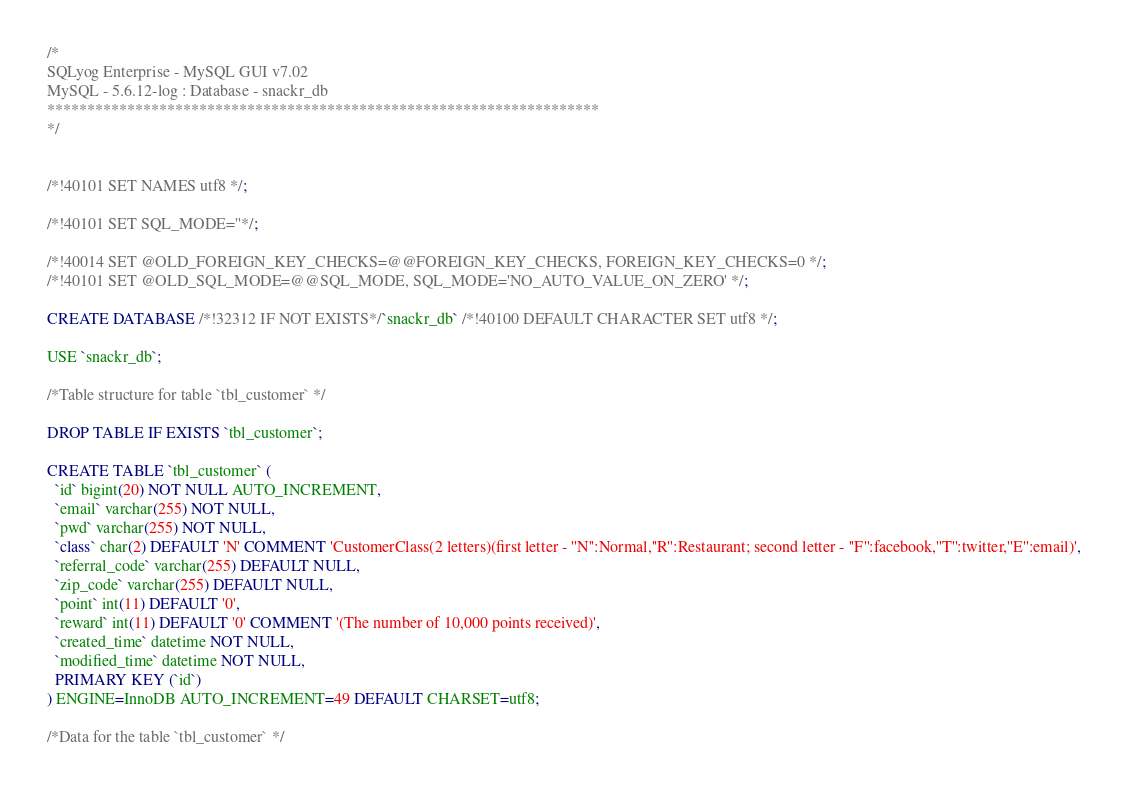Convert code to text. <code><loc_0><loc_0><loc_500><loc_500><_SQL_>/*
SQLyog Enterprise - MySQL GUI v7.02 
MySQL - 5.6.12-log : Database - snackr_db
*********************************************************************
*/

/*!40101 SET NAMES utf8 */;

/*!40101 SET SQL_MODE=''*/;

/*!40014 SET @OLD_FOREIGN_KEY_CHECKS=@@FOREIGN_KEY_CHECKS, FOREIGN_KEY_CHECKS=0 */;
/*!40101 SET @OLD_SQL_MODE=@@SQL_MODE, SQL_MODE='NO_AUTO_VALUE_ON_ZERO' */;

CREATE DATABASE /*!32312 IF NOT EXISTS*/`snackr_db` /*!40100 DEFAULT CHARACTER SET utf8 */;

USE `snackr_db`;

/*Table structure for table `tbl_customer` */

DROP TABLE IF EXISTS `tbl_customer`;

CREATE TABLE `tbl_customer` (
  `id` bigint(20) NOT NULL AUTO_INCREMENT,
  `email` varchar(255) NOT NULL,
  `pwd` varchar(255) NOT NULL,
  `class` char(2) DEFAULT 'N' COMMENT 'CustomerClass(2 letters)(first letter - ''N'':Normal,''R'':Restaurant; second letter - ''F'':facebook,''T'':twitter,''E'':email)',
  `referral_code` varchar(255) DEFAULT NULL,
  `zip_code` varchar(255) DEFAULT NULL,
  `point` int(11) DEFAULT '0',
  `reward` int(11) DEFAULT '0' COMMENT '(The number of 10,000 points received)',
  `created_time` datetime NOT NULL,
  `modified_time` datetime NOT NULL,
  PRIMARY KEY (`id`)
) ENGINE=InnoDB AUTO_INCREMENT=49 DEFAULT CHARSET=utf8;

/*Data for the table `tbl_customer` */
</code> 